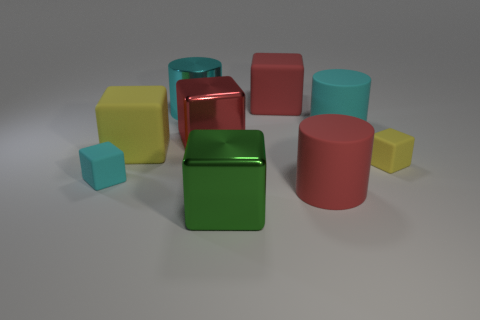Subtract all big red rubber blocks. How many blocks are left? 5 Subtract 2 cubes. How many cubes are left? 4 Subtract all yellow blocks. How many blocks are left? 4 Subtract all yellow blocks. Subtract all purple cylinders. How many blocks are left? 4 Subtract all blocks. How many objects are left? 3 Add 2 metal blocks. How many metal blocks are left? 4 Add 2 large cyan blocks. How many large cyan blocks exist? 2 Subtract 1 cyan blocks. How many objects are left? 8 Subtract all big red objects. Subtract all small gray rubber cylinders. How many objects are left? 6 